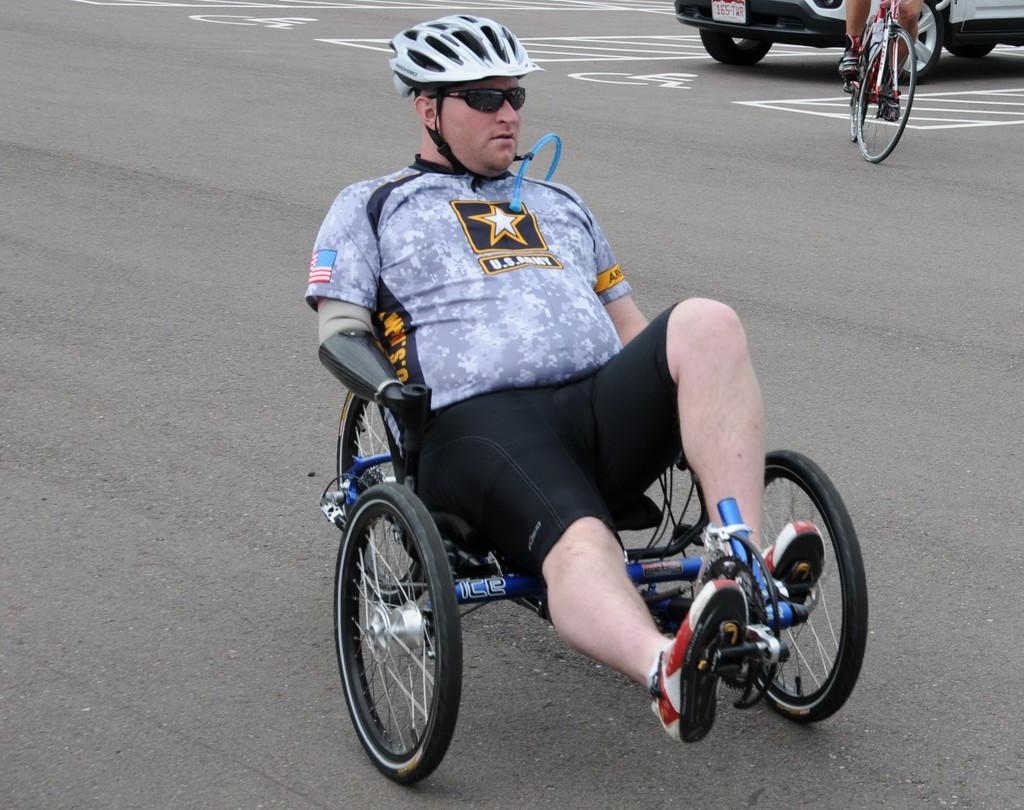What is the person in the foreground of the image doing? The person is sitting on a tricycle in the image. What can be seen in the background of the image? There is a motor vehicle on the road and a person riding a bicycle in the background of the image. How many hammers are visible in the image? There are no hammers visible in the image. 